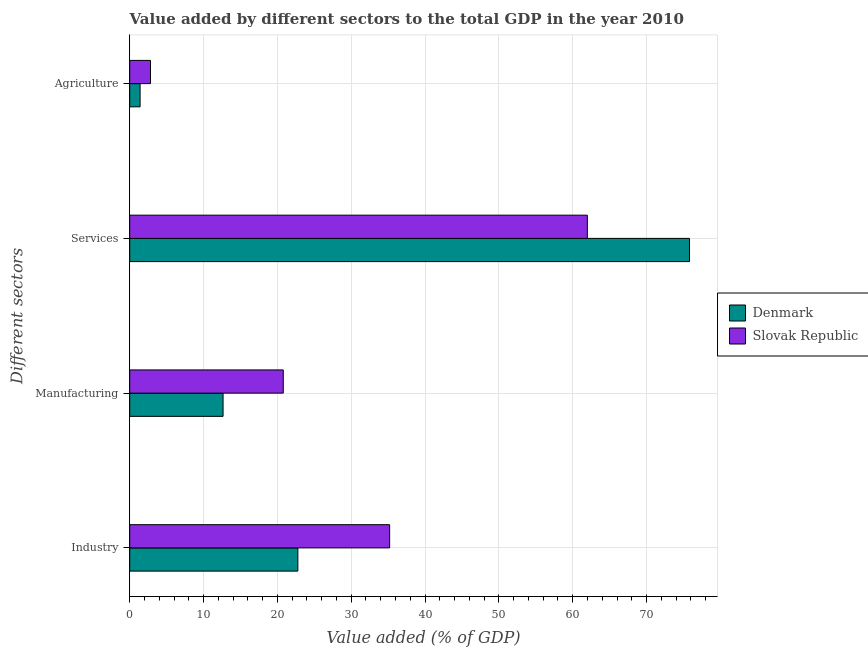How many groups of bars are there?
Give a very brief answer. 4. Are the number of bars per tick equal to the number of legend labels?
Provide a short and direct response. Yes. How many bars are there on the 4th tick from the top?
Offer a terse response. 2. What is the label of the 1st group of bars from the top?
Your answer should be very brief. Agriculture. What is the value added by agricultural sector in Slovak Republic?
Make the answer very short. 2.81. Across all countries, what is the maximum value added by services sector?
Make the answer very short. 75.82. Across all countries, what is the minimum value added by agricultural sector?
Provide a short and direct response. 1.4. In which country was the value added by manufacturing sector maximum?
Give a very brief answer. Slovak Republic. In which country was the value added by services sector minimum?
Your answer should be very brief. Slovak Republic. What is the total value added by manufacturing sector in the graph?
Give a very brief answer. 33.44. What is the difference between the value added by manufacturing sector in Slovak Republic and that in Denmark?
Offer a very short reply. 8.15. What is the difference between the value added by services sector in Denmark and the value added by industrial sector in Slovak Republic?
Keep it short and to the point. 40.62. What is the average value added by services sector per country?
Offer a terse response. 68.9. What is the difference between the value added by services sector and value added by industrial sector in Denmark?
Make the answer very short. 53.05. What is the ratio of the value added by manufacturing sector in Denmark to that in Slovak Republic?
Keep it short and to the point. 0.61. What is the difference between the highest and the second highest value added by industrial sector?
Ensure brevity in your answer.  12.43. What is the difference between the highest and the lowest value added by services sector?
Provide a short and direct response. 13.84. Is it the case that in every country, the sum of the value added by agricultural sector and value added by services sector is greater than the sum of value added by manufacturing sector and value added by industrial sector?
Provide a succinct answer. Yes. What does the 2nd bar from the top in Services represents?
Your response must be concise. Denmark. How many countries are there in the graph?
Provide a short and direct response. 2. What is the difference between two consecutive major ticks on the X-axis?
Keep it short and to the point. 10. Are the values on the major ticks of X-axis written in scientific E-notation?
Your response must be concise. No. Does the graph contain any zero values?
Ensure brevity in your answer.  No. Does the graph contain grids?
Offer a very short reply. Yes. What is the title of the graph?
Make the answer very short. Value added by different sectors to the total GDP in the year 2010. Does "Bulgaria" appear as one of the legend labels in the graph?
Your answer should be very brief. No. What is the label or title of the X-axis?
Your answer should be very brief. Value added (% of GDP). What is the label or title of the Y-axis?
Keep it short and to the point. Different sectors. What is the Value added (% of GDP) in Denmark in Industry?
Provide a short and direct response. 22.77. What is the Value added (% of GDP) of Slovak Republic in Industry?
Keep it short and to the point. 35.2. What is the Value added (% of GDP) of Denmark in Manufacturing?
Your response must be concise. 12.64. What is the Value added (% of GDP) of Slovak Republic in Manufacturing?
Make the answer very short. 20.8. What is the Value added (% of GDP) in Denmark in Services?
Provide a short and direct response. 75.82. What is the Value added (% of GDP) of Slovak Republic in Services?
Your answer should be very brief. 61.98. What is the Value added (% of GDP) in Denmark in Agriculture?
Offer a terse response. 1.4. What is the Value added (% of GDP) in Slovak Republic in Agriculture?
Your answer should be compact. 2.81. Across all Different sectors, what is the maximum Value added (% of GDP) in Denmark?
Provide a succinct answer. 75.82. Across all Different sectors, what is the maximum Value added (% of GDP) of Slovak Republic?
Ensure brevity in your answer.  61.98. Across all Different sectors, what is the minimum Value added (% of GDP) of Denmark?
Give a very brief answer. 1.4. Across all Different sectors, what is the minimum Value added (% of GDP) in Slovak Republic?
Make the answer very short. 2.81. What is the total Value added (% of GDP) in Denmark in the graph?
Make the answer very short. 112.64. What is the total Value added (% of GDP) in Slovak Republic in the graph?
Keep it short and to the point. 120.8. What is the difference between the Value added (% of GDP) of Denmark in Industry and that in Manufacturing?
Offer a terse response. 10.13. What is the difference between the Value added (% of GDP) of Slovak Republic in Industry and that in Manufacturing?
Keep it short and to the point. 14.41. What is the difference between the Value added (% of GDP) of Denmark in Industry and that in Services?
Your answer should be very brief. -53.05. What is the difference between the Value added (% of GDP) of Slovak Republic in Industry and that in Services?
Make the answer very short. -26.78. What is the difference between the Value added (% of GDP) in Denmark in Industry and that in Agriculture?
Provide a short and direct response. 21.37. What is the difference between the Value added (% of GDP) of Slovak Republic in Industry and that in Agriculture?
Your answer should be very brief. 32.39. What is the difference between the Value added (% of GDP) in Denmark in Manufacturing and that in Services?
Your response must be concise. -63.18. What is the difference between the Value added (% of GDP) of Slovak Republic in Manufacturing and that in Services?
Provide a succinct answer. -41.19. What is the difference between the Value added (% of GDP) of Denmark in Manufacturing and that in Agriculture?
Provide a short and direct response. 11.24. What is the difference between the Value added (% of GDP) of Slovak Republic in Manufacturing and that in Agriculture?
Provide a succinct answer. 17.98. What is the difference between the Value added (% of GDP) of Denmark in Services and that in Agriculture?
Your answer should be very brief. 74.42. What is the difference between the Value added (% of GDP) in Slovak Republic in Services and that in Agriculture?
Provide a succinct answer. 59.17. What is the difference between the Value added (% of GDP) of Denmark in Industry and the Value added (% of GDP) of Slovak Republic in Manufacturing?
Provide a succinct answer. 1.98. What is the difference between the Value added (% of GDP) of Denmark in Industry and the Value added (% of GDP) of Slovak Republic in Services?
Give a very brief answer. -39.21. What is the difference between the Value added (% of GDP) of Denmark in Industry and the Value added (% of GDP) of Slovak Republic in Agriculture?
Provide a succinct answer. 19.96. What is the difference between the Value added (% of GDP) of Denmark in Manufacturing and the Value added (% of GDP) of Slovak Republic in Services?
Offer a very short reply. -49.34. What is the difference between the Value added (% of GDP) of Denmark in Manufacturing and the Value added (% of GDP) of Slovak Republic in Agriculture?
Your response must be concise. 9.83. What is the difference between the Value added (% of GDP) of Denmark in Services and the Value added (% of GDP) of Slovak Republic in Agriculture?
Make the answer very short. 73.01. What is the average Value added (% of GDP) of Denmark per Different sectors?
Make the answer very short. 28.16. What is the average Value added (% of GDP) in Slovak Republic per Different sectors?
Make the answer very short. 30.2. What is the difference between the Value added (% of GDP) of Denmark and Value added (% of GDP) of Slovak Republic in Industry?
Offer a terse response. -12.43. What is the difference between the Value added (% of GDP) of Denmark and Value added (% of GDP) of Slovak Republic in Manufacturing?
Ensure brevity in your answer.  -8.15. What is the difference between the Value added (% of GDP) of Denmark and Value added (% of GDP) of Slovak Republic in Services?
Your response must be concise. 13.84. What is the difference between the Value added (% of GDP) of Denmark and Value added (% of GDP) of Slovak Republic in Agriculture?
Offer a terse response. -1.41. What is the ratio of the Value added (% of GDP) in Denmark in Industry to that in Manufacturing?
Your response must be concise. 1.8. What is the ratio of the Value added (% of GDP) in Slovak Republic in Industry to that in Manufacturing?
Give a very brief answer. 1.69. What is the ratio of the Value added (% of GDP) of Denmark in Industry to that in Services?
Give a very brief answer. 0.3. What is the ratio of the Value added (% of GDP) of Slovak Republic in Industry to that in Services?
Offer a terse response. 0.57. What is the ratio of the Value added (% of GDP) of Denmark in Industry to that in Agriculture?
Keep it short and to the point. 16.22. What is the ratio of the Value added (% of GDP) in Slovak Republic in Industry to that in Agriculture?
Provide a succinct answer. 12.52. What is the ratio of the Value added (% of GDP) in Slovak Republic in Manufacturing to that in Services?
Your answer should be compact. 0.34. What is the ratio of the Value added (% of GDP) in Denmark in Manufacturing to that in Agriculture?
Your answer should be compact. 9. What is the ratio of the Value added (% of GDP) in Slovak Republic in Manufacturing to that in Agriculture?
Your answer should be very brief. 7.4. What is the ratio of the Value added (% of GDP) in Denmark in Services to that in Agriculture?
Offer a terse response. 54.01. What is the ratio of the Value added (% of GDP) of Slovak Republic in Services to that in Agriculture?
Make the answer very short. 22.05. What is the difference between the highest and the second highest Value added (% of GDP) of Denmark?
Provide a succinct answer. 53.05. What is the difference between the highest and the second highest Value added (% of GDP) in Slovak Republic?
Your response must be concise. 26.78. What is the difference between the highest and the lowest Value added (% of GDP) of Denmark?
Provide a short and direct response. 74.42. What is the difference between the highest and the lowest Value added (% of GDP) in Slovak Republic?
Offer a very short reply. 59.17. 